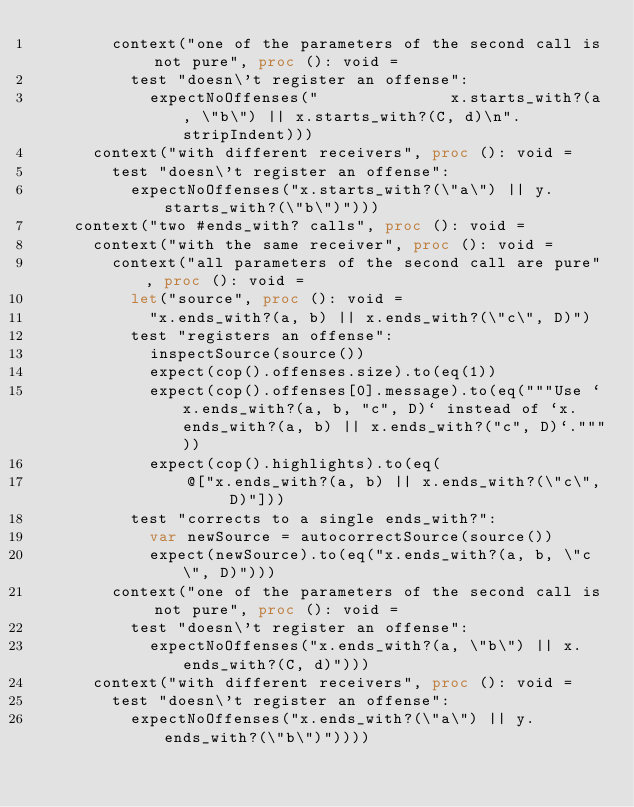<code> <loc_0><loc_0><loc_500><loc_500><_Nim_>        context("one of the parameters of the second call is not pure", proc (): void =
          test "doesn\'t register an offense":
            expectNoOffenses("              x.starts_with?(a, \"b\") || x.starts_with?(C, d)\n".stripIndent)))
      context("with different receivers", proc (): void =
        test "doesn\'t register an offense":
          expectNoOffenses("x.starts_with?(\"a\") || y.starts_with?(\"b\")")))
    context("two #ends_with? calls", proc (): void =
      context("with the same receiver", proc (): void =
        context("all parameters of the second call are pure", proc (): void =
          let("source", proc (): void =
            "x.ends_with?(a, b) || x.ends_with?(\"c\", D)")
          test "registers an offense":
            inspectSource(source())
            expect(cop().offenses.size).to(eq(1))
            expect(cop().offenses[0].message).to(eq("""Use `x.ends_with?(a, b, "c", D)` instead of `x.ends_with?(a, b) || x.ends_with?("c", D)`."""))
            expect(cop().highlights).to(eq(
                @["x.ends_with?(a, b) || x.ends_with?(\"c\", D)"]))
          test "corrects to a single ends_with?":
            var newSource = autocorrectSource(source())
            expect(newSource).to(eq("x.ends_with?(a, b, \"c\", D)")))
        context("one of the parameters of the second call is not pure", proc (): void =
          test "doesn\'t register an offense":
            expectNoOffenses("x.ends_with?(a, \"b\") || x.ends_with?(C, d)")))
      context("with different receivers", proc (): void =
        test "doesn\'t register an offense":
          expectNoOffenses("x.ends_with?(\"a\") || y.ends_with?(\"b\")"))))
</code> 